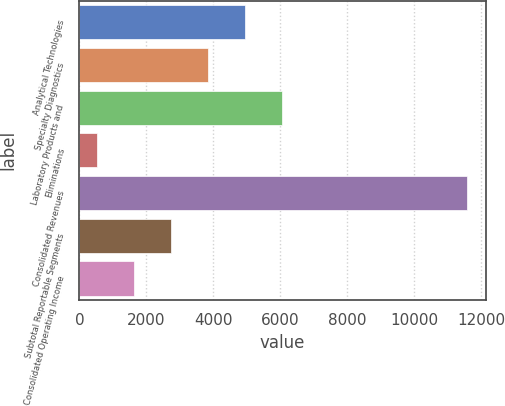Convert chart to OTSL. <chart><loc_0><loc_0><loc_500><loc_500><bar_chart><fcel>Analytical Technologies<fcel>Specialty Diagnostics<fcel>Laboratory Products and<fcel>Eliminations<fcel>Consolidated Revenues<fcel>Subtotal Reportable Segments<fcel>Consolidated Operating Income<nl><fcel>4935.16<fcel>3831.22<fcel>6039.1<fcel>519.4<fcel>11558.8<fcel>2727.28<fcel>1623.34<nl></chart> 